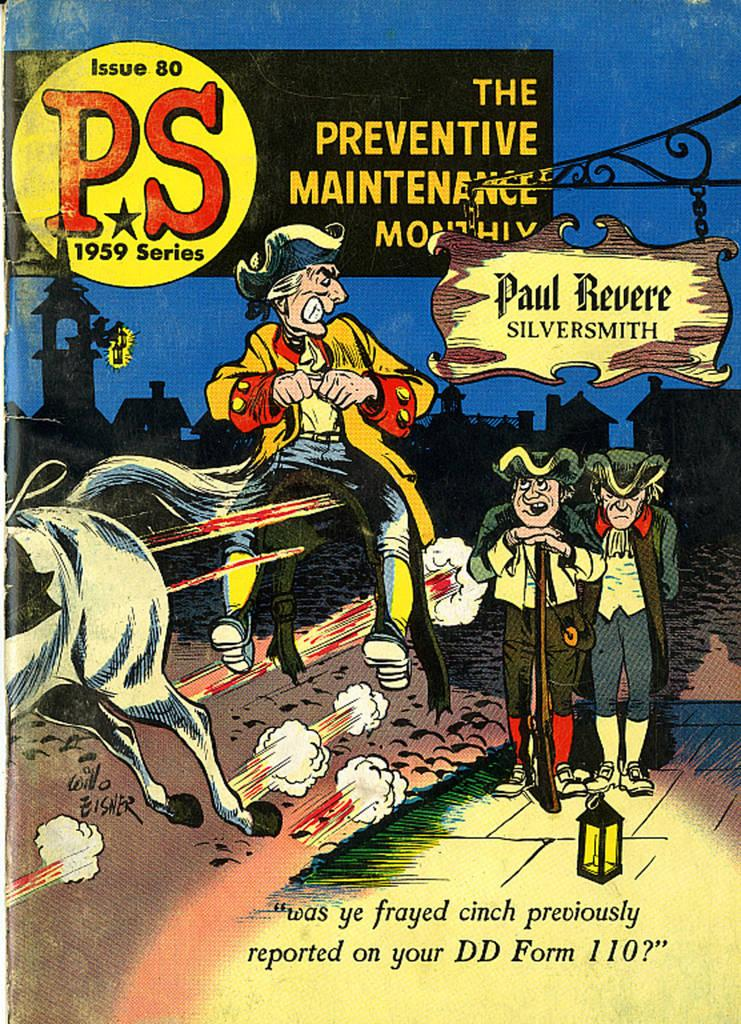<image>
Create a compact narrative representing the image presented. Preventive Maintenance monthly from the Paul Revere Silversmith that is Issue 80 PS 1959 Series. 